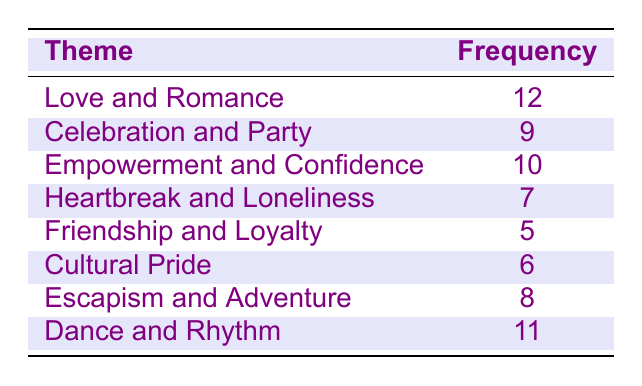What is the most common theme in the lyrics? The table shows that "Love and Romance" has the highest frequency of 12, making it the most common theme among the listed themes.
Answer: Love and Romance How many themes have a frequency greater than 8? The themes with frequencies greater than 8 are: "Love and Romance" (12), "Empowerment and Confidence" (10), "Dance and Rhythm" (11), "Celebration and Party" (9), and "Escapism and Adventure" (8). Counting these themes gives a total of 5.
Answer: 5 Is "Cultural Pride" one of the top three most common themes? The frequencies in the table show that "Cultural Pride" has a frequency of 6, which is less than the frequencies of "Love and Romance" (12), "Dance and Rhythm" (11), and "Empowerment and Confidence" (10). Thus, it is not one of the top three themes.
Answer: No What is the average frequency of the themes? To find the average, I first sum the frequencies: 12 + 9 + 10 + 7 + 5 + 6 + 8 + 11 = 68. There are 8 themes, so the average frequency is 68 divided by 8, which equals 8.5.
Answer: 8.5 Which theme has the lowest frequency, and what is that frequency? The theme "Friendship and Loyalty" has the lowest frequency in the table, at 5.
Answer: Friendship and Loyalty, 5 What is the difference in frequency between the "Dance and Rhythm" and "Heartbreak and Loneliness" themes? The frequency of "Dance and Rhythm" is 11 and "Heartbreak and Loneliness" is 7. The difference is calculated by subtracting 7 from 11, which gives 4.
Answer: 4 How many themes are related to positive emotions such as celebration, empowerment, and romance? The themes related to positive emotions are "Love and Romance" (12), "Celebration and Party" (9), and "Empowerment and Confidence" (10). Counting these gives a total of 3 themes.
Answer: 3 Which is the second most frequent theme based on the table? By checking the frequencies, "Dance and Rhythm" follows "Love and Romance" and is the second most frequent with a value of 11.
Answer: Dance and Rhythm 